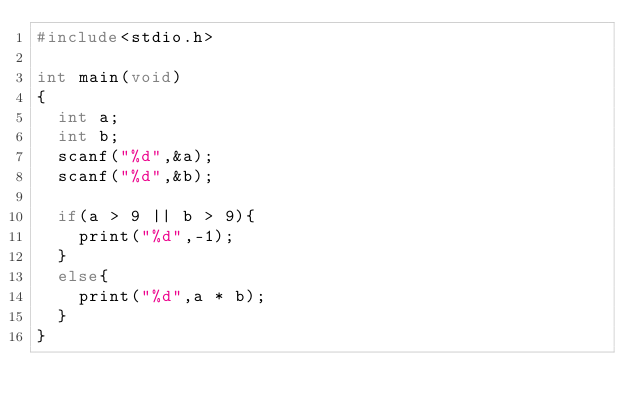Convert code to text. <code><loc_0><loc_0><loc_500><loc_500><_C_>#include<stdio.h>

int main(void)
{
  int a;
  int b;
  scanf("%d",&a);
  scanf("%d",&b);
  
  if(a > 9 || b > 9){
    print("%d",-1);
  }
  else{
    print("%d",a * b);
  }
}</code> 